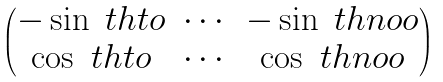Convert formula to latex. <formula><loc_0><loc_0><loc_500><loc_500>\begin{pmatrix} - \sin \ t h t o & \cdots & - \sin \ t h n o o \\ \cos \ t h t o & \cdots & \cos \ t h n o o \end{pmatrix}</formula> 